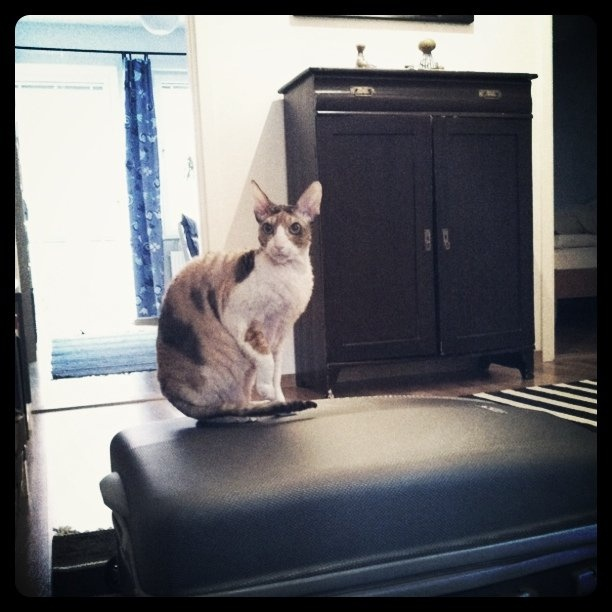Describe the objects in this image and their specific colors. I can see suitcase in black, gray, and darkgray tones and cat in black, darkgray, and gray tones in this image. 